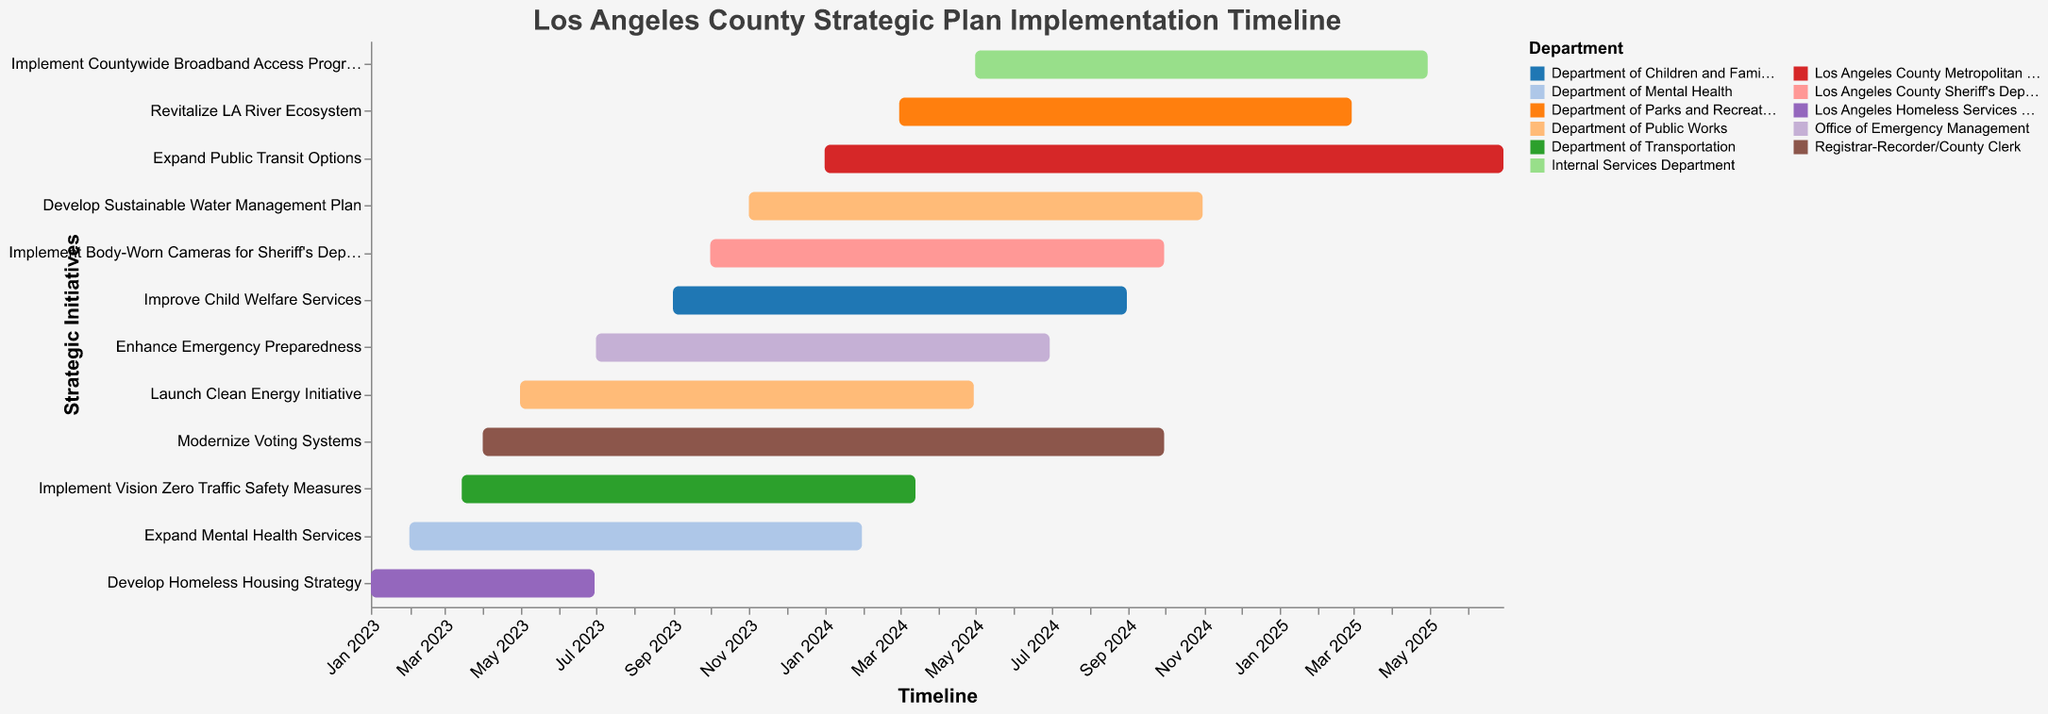What is the title of the Gantt chart? The title of the Gantt chart is displayed at the top and summarizes what the chart is about.
Answer: Los Angeles County Strategic Plan Implementation Timeline Which department is responsible for the longest strategic initiative? To find this, identify the task with the longest bar and note the associated department.
Answer: Los Angeles County Metropolitan Transportation Authority Which strategic initiative starts last and when does it start? Identify the bar that starts latest on the timeline (furthest to the right on the x-axis) and check its starting date.
Answer: Implement Countywide Broadband Access Program, May 1, 2024 How many tasks are being undertaken by the Department of Public Works? Count the number of bars associated with the Department of Public Works by checking the legend colors.
Answer: 2 What is the duration of "Implement Vision Zero Traffic Safety Measures"? Calculate the duration by subtracting the start date from the end date of this particular initiative.
Answer: One year minus one day Which department has initiatives that start in 2024? Look for bars that start in 2024 and refer to the associated departments.
Answer: Los Angeles County Metropolitan Transportation Authority, Department of Parks and Recreation, Internal Services Department When does the "Expand Mental Health Services" initiative end? Find the end date of that specific initiative by referring to its corresponding bar on the timeline.
Answer: January 31, 2024 Which two initiatives have overlapping time periods? Identify any bars that visually overlap on the timeline and cross-reference their task names.
Answer: Modernize Voting Systems and Launch Clean Energy Initiative What is the total number of distinct departments involved in the strategic plan? Count the unique departments listed in the legend.
Answer: 11 Which initiative has the shortest duration and what is that duration? Identify the bar with the shortest length and calculate its duration by subtracting the start date from the end date.
Answer: Develop Homeless Housing Strategy, six months 